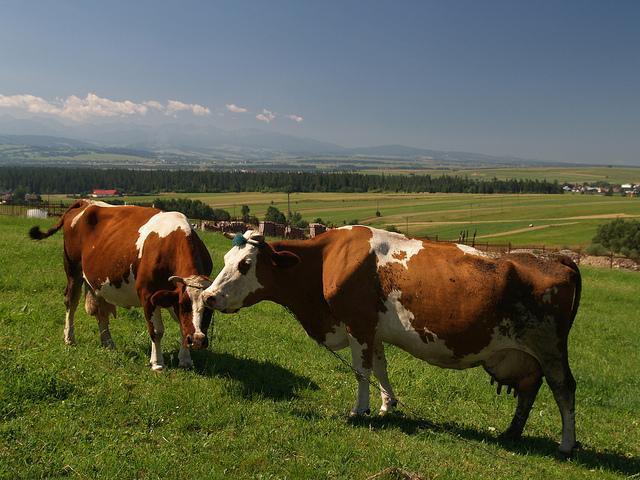How many cows are present?
Give a very brief answer. 2. How many cows are there?
Give a very brief answer. 2. 